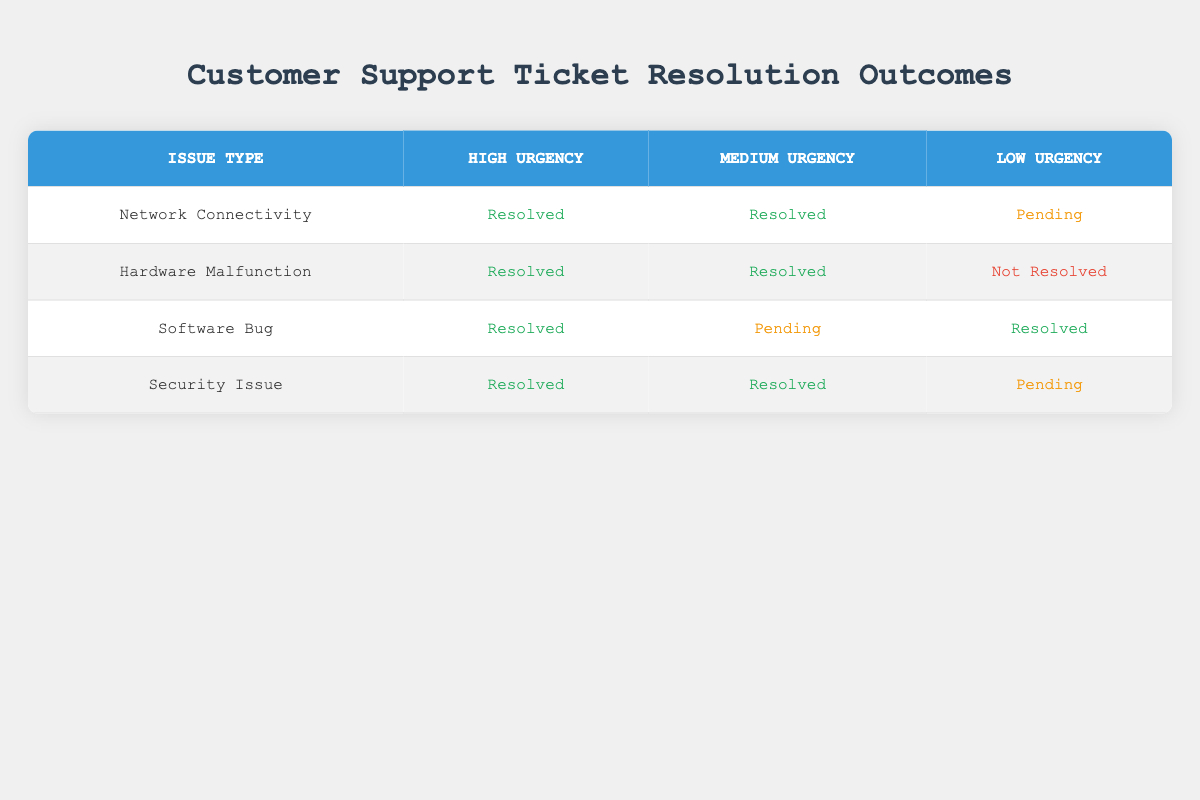What are the resolution outcomes for Network Connectivity issues? According to the table, Network Connectivity issues have a resolution outcome of "Resolved" for both High and Medium urgency, while for Low urgency, it is "Pending."
Answer: Resolved, Resolved, Pending How many issue types have a resolution outcome of "Not Resolved"? The table shows that only Hardware Malfunction has a resolution outcome of "Not Resolved" for Low urgency. Thus, there is 1 issue type with this outcome.
Answer: 1 What is the resolution outcome for Software Bug at Medium urgency? The table indicates that the resolution outcome for Software Bug at Medium urgency is "Pending."
Answer: Pending Is there any issue type with a resolution outcome of "Pending" for High urgency? Looking at the table data, none of the issue types have "Pending" as a resolution outcome for High urgency; instead, all are "Resolved."
Answer: No For Hardware Malfunction, what is the difference in resolution outcomes between Medium and Low urgency? For Medium urgency under Hardware Malfunction, the outcome is "Resolved," whereas for Low urgency, it is "Not Resolved." The difference in outcomes is therefore Resolved vs. Not Resolved.
Answer: Resolved vs. Not Resolved How many total issues are listed in the table, and what percentage are resolved? There are 12 tickets in total. The resolved outcomes are (6 from Network Connectivity, Hardware Malfunction, Software Bug, and Security Issue combined), totaling 8. The percentage of resolved issues is (8/12) * 100 = 66.67%.
Answer: 66.67% Which urgency level has the highest number of "Resolved" outcomes? By counting the outcomes, High urgency has 4 "Resolved," Medium urgency also has 4 "Resolved," and Low urgency has 4 combined (but each type varies). Therefore, urgency levels are equal in terms of the resolved count.
Answer: Equal How many resolution outcomes are "Resolved" across all issue types? By examining the table data, the resolution outcomes that are "Resolved" total to 8 (2 from each issue type in High and Medium urgencies and 2 from Software Bug and Hardware Malfunction in Low urgency).
Answer: 8 